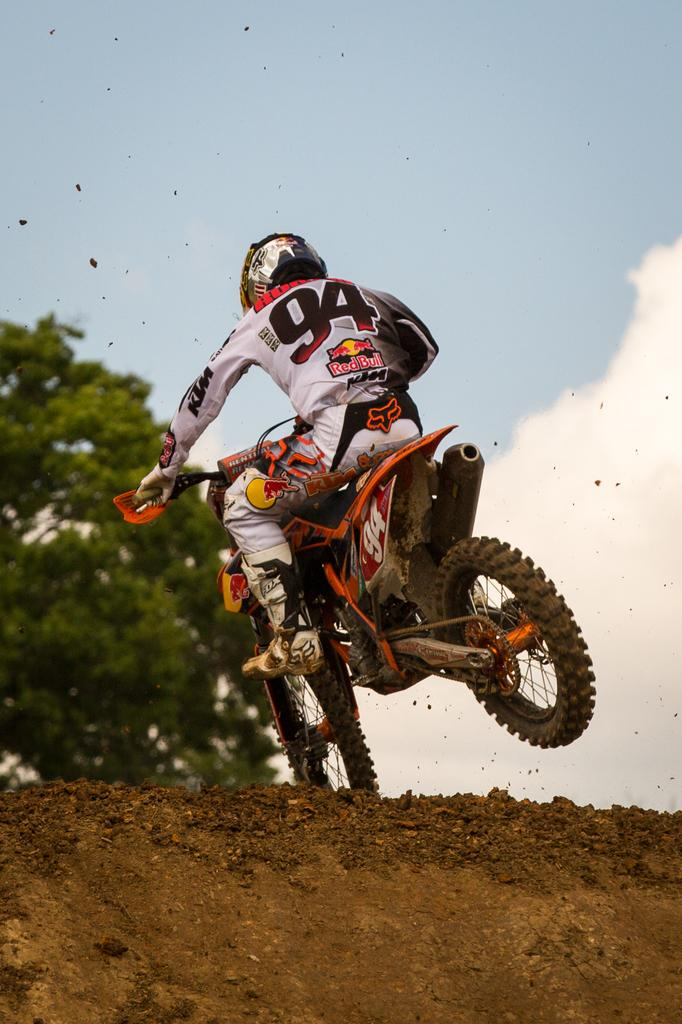What is the person in the image doing? The person is riding a bike in the image. Where is the person riding the bike? The person is on land. What safety gear is the person wearing? The person is wearing a helmet. What can be seen on the left side of the image? There is a tree on the left side of the image. What is visible in the background of the image? The sky is visible in the background of the image, and there are clouds in the sky. What invention is the person using to copy the tree in the image? There is no invention or copying activity present in the image; the person is simply riding a bike. 